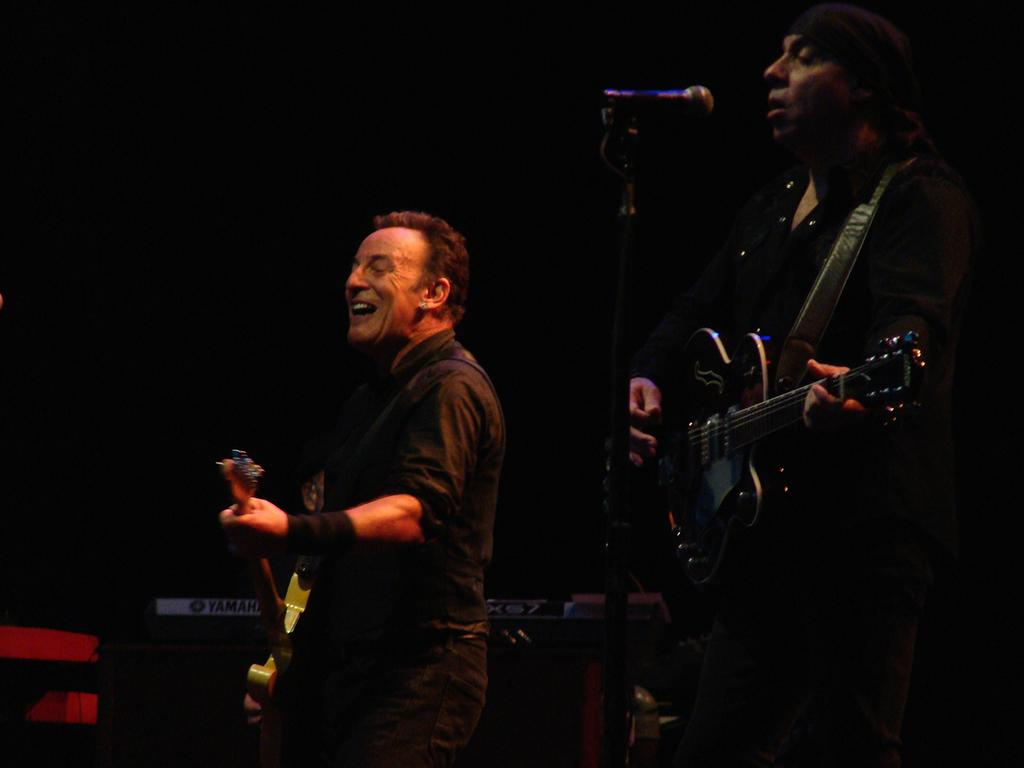How many people are in the image? There are two persons in the image. What are the persons holding in the image? The persons are holding guitars. Can you describe the position of one of the persons in relation to a microphone? One person is standing in front of a microphone. What type of beetle can be seen crawling on the guitar in the image? There is no beetle present in the image; it only features two persons holding guitars and one standing in front of a microphone. 